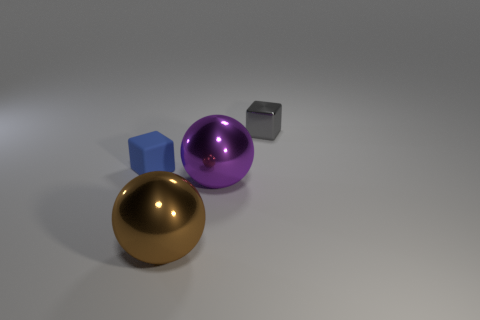What shape is the small gray thing behind the purple sphere? The small gray object positioned behind the purple sphere is a cube. It has six faces, each of which is a square, and it embodies a three-dimensional shape with equal edge lengths. 